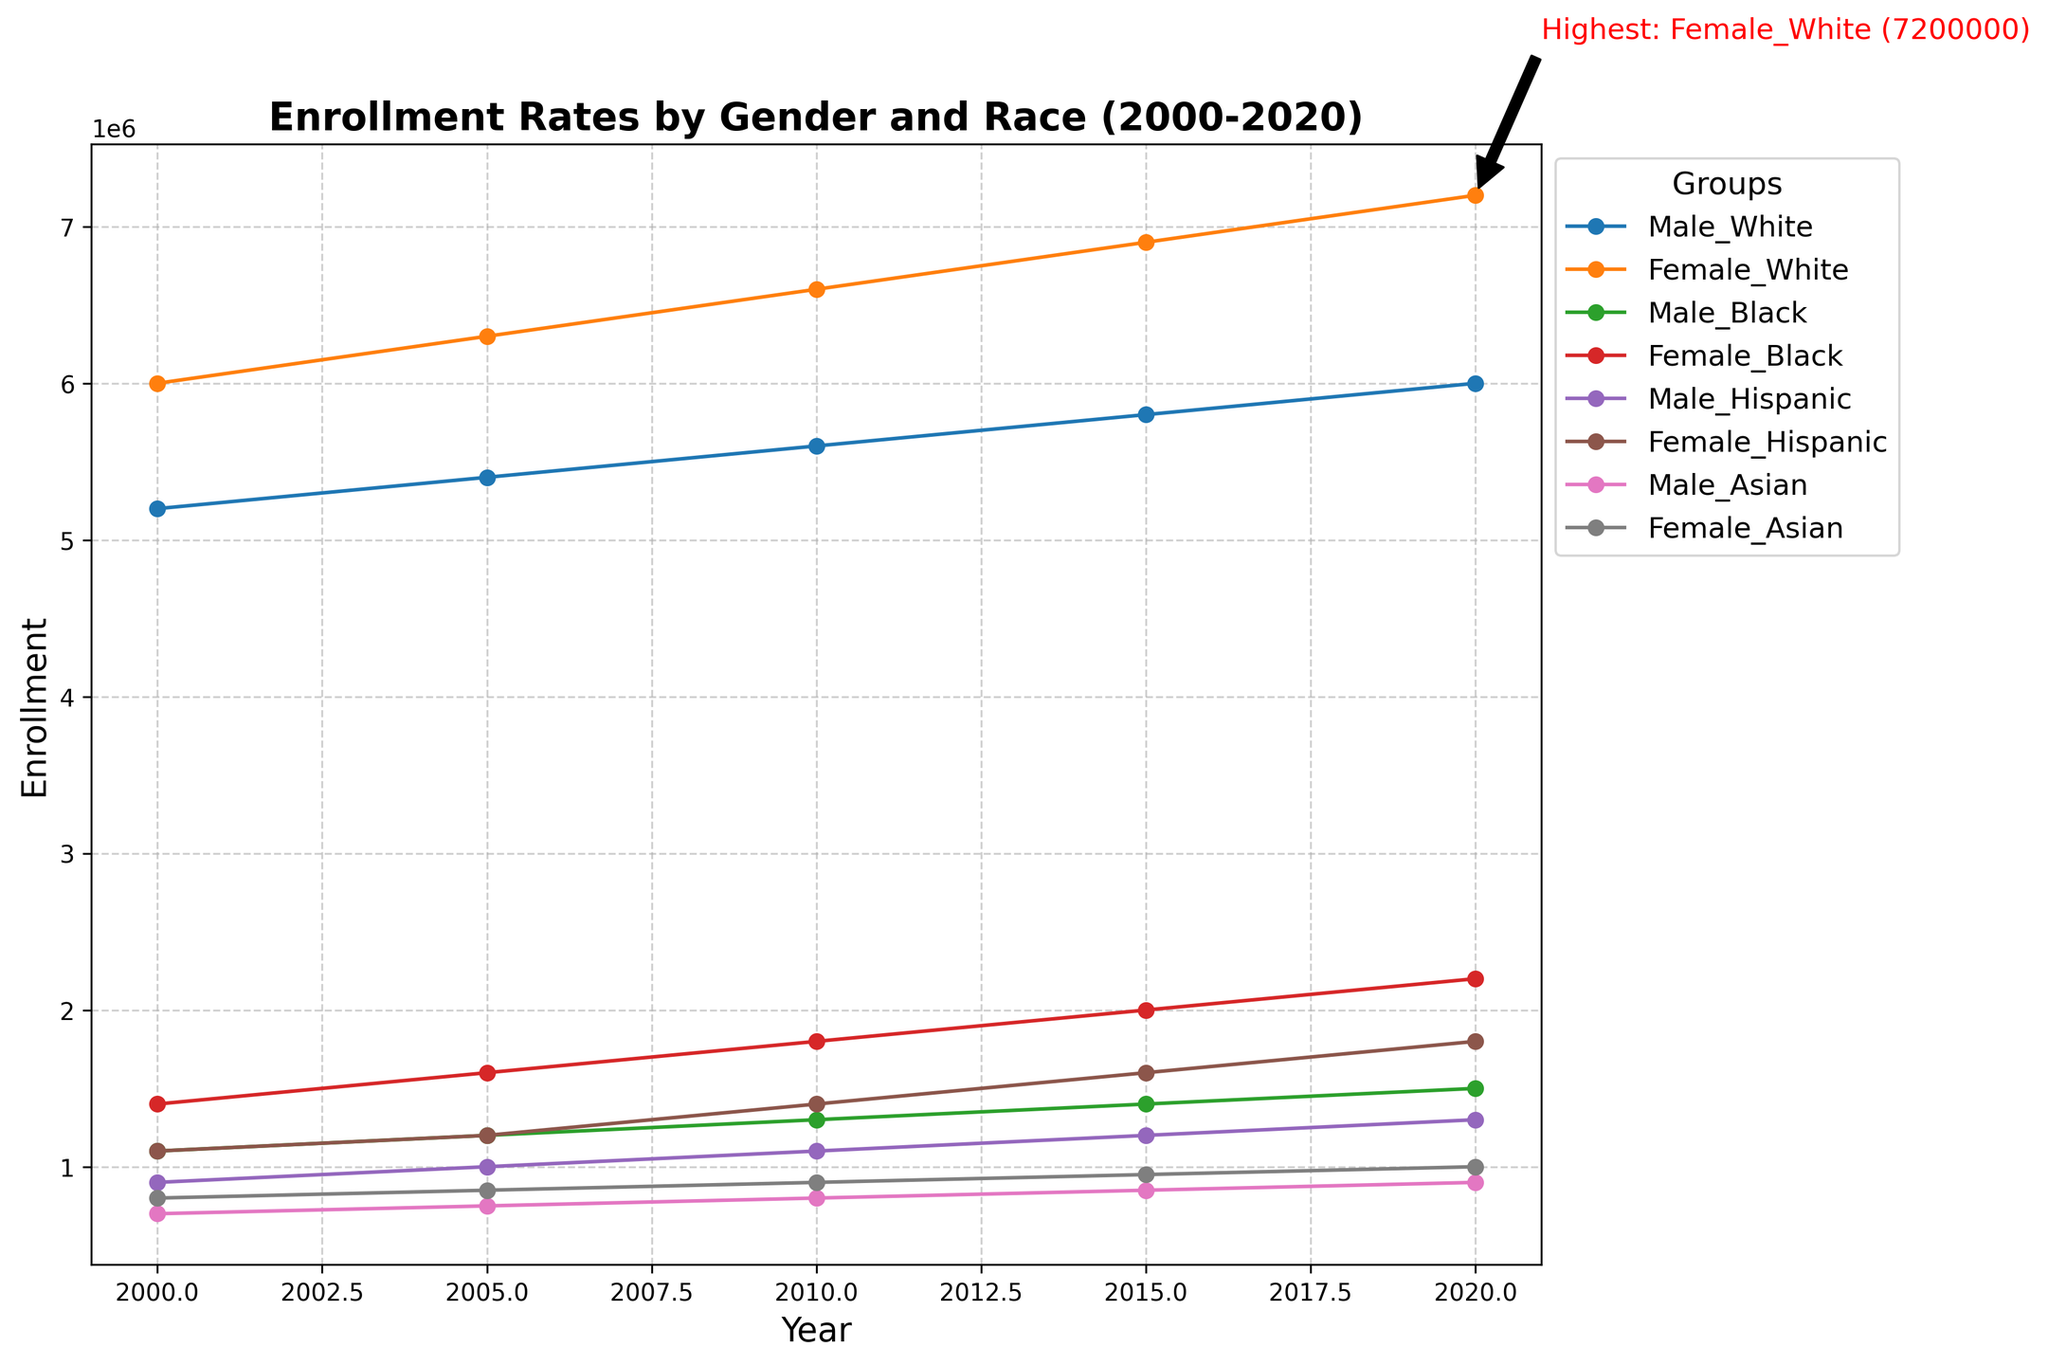What is the enrollment difference between Female_White and Male_White in 2020? To find the enrollment difference between Female_White and Male_White in 2020, subtract the Male_White enrollment from the Female_White enrollment. The Female_White enrollment in 2020 is 7200000, and the Male_White enrollment is 6000000. Thus, 7200000 - 6000000 = 1200000
Answer: 1200000 Which group had the highest enrollment in 2015? By observing the 2015 year on the x-axis, we can see the trend lines for all groups. The highest y-value in 2015 is for the Female_White group, which is around 6900000.
Answer: Female_White How has the enrollment trend of Female_Hispanic changed from 2000 to 2020? To answer this, examine and compare the y-values of Female_Hispanic in 2000 and 2020. In 2000, the enrollment was 1100000. By 2020, it increased to 1800000, indicating a rising trend.
Answer: Rising trend Which group had the highest enrollment overall, and what was the value? The annotation on the plot highlights the group with the highest enrollment overall. According to the annotation, the highest enrollment was Female_White with a value of 7200000 in 2020.
Answer: Female_White with 7200000 Between Male_Asian and Female_Asian, which group had a higher enrollment in 2010, and by how much? Compare the enrollment of Male_Asian and Female_Asian in 2010. Male_Asian had 800000, and Female_Asian had 900000. The difference is 900000 - 800000 = 100000.
Answer: Female_Asian by 100000 Looking at trends between 2000 and 2020, which group saw the largest relative increase in enrollment? To find the group with the largest relative increase, calculate the percentage change for each group from 2000 to 2020. Male_Black increased from 1100000 to 1500000, a (1500000-1100000)/1100000 ≈ 36% increase; consider other groups similarly. Female_Black increased from 1400000 to 2200000, a (2200000-1400000)/1400000 ≈ 57% increase, making her the largest relative increase.
Answer: Female_Black Did Male_Hispanic enrollment ever surpass Male_Black enrollment between 2000 and 2020? Analyze the line for both Male_Hispanic and Male_Black between 2000 and 2020. At no point does the Male_Hispanic line surpass the Male_Black line.
Answer: No What was the enrollment of Female_Black in 2010, and how did it change by 2020? The enrollment for Female_Black in 2010 was 1800000. By 2020, it increased to 2200000. The change is 2200000 - 1800000 = 400000.
Answer: 1800000; increased by 400000 Among all groups, which one had the smallest growth in enrollment from 2000 to 2020? To determine the smallest growth, calculate the change in enrollment for each group from 2000 to 2020. The group with the smallest absolute increase is Male_Asian, changing from 700000 to 900000, an increase of 200000.
Answer: Male_Asian 